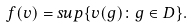<formula> <loc_0><loc_0><loc_500><loc_500>f ( v ) = s u p \{ v ( g ) \colon g \in D \} .</formula> 